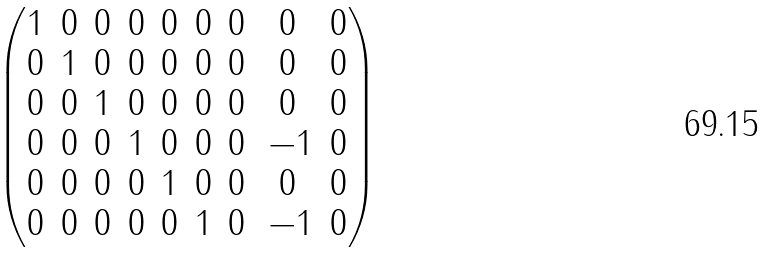Convert formula to latex. <formula><loc_0><loc_0><loc_500><loc_500>\begin{pmatrix} 1 & 0 & 0 & 0 & 0 & 0 & 0 & 0 & 0 \\ 0 & 1 & 0 & 0 & 0 & 0 & 0 & 0 & 0 \\ 0 & 0 & 1 & 0 & 0 & 0 & 0 & 0 & 0 \\ 0 & 0 & 0 & 1 & 0 & 0 & 0 & \, - 1 & 0 \\ 0 & 0 & 0 & 0 & 1 & 0 & 0 & 0 & 0 \\ 0 & 0 & 0 & 0 & 0 & 1 & 0 & \, - 1 & 0 \end{pmatrix}</formula> 